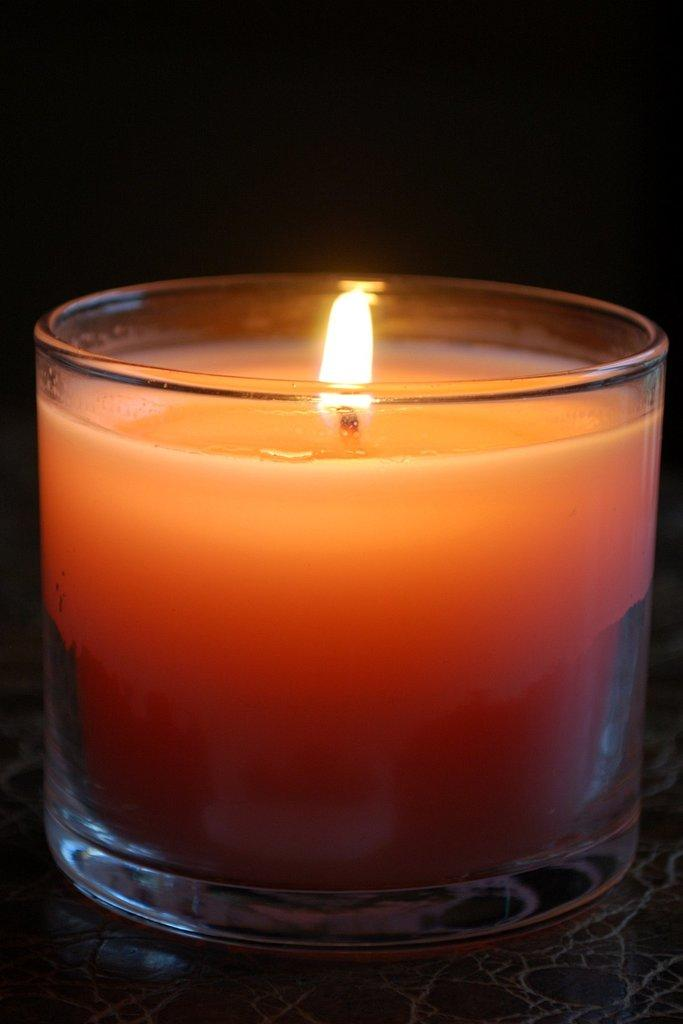What type of candle is visible in the image? There is a glass candle in the image. Where is the glass candle located? The glass candle is on a surface. What type of star is visible in the image? There is no star visible in the image; it only features a glass candle on a surface. What kind of band is performing in the image? There is no band present in the image; it only features a glass candle on a surface. 